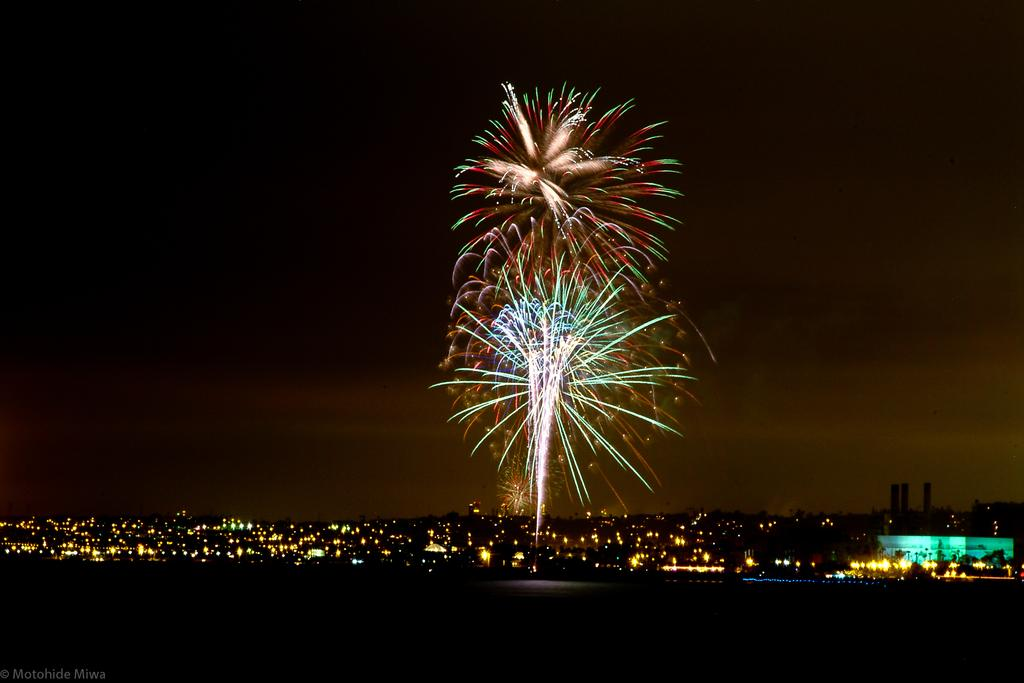What is located at the bottom of the image? There are lights at the bottom of the image. What type of structures can be seen in the image? There are buildings in the image. What other natural elements are present in the image? There are trees in the image. What is the main event happening in the image? Fireworks are present in the image. How would you describe the overall lighting in the image? The background of the image is dark. What word is being spelled out by the lights at the bottom of the image? There is no word being spelled out by the lights in the image; they are simply lights. What type of treatment is being administered to the trees in the image? There is no treatment being administered to the trees in the image; they are just trees. 